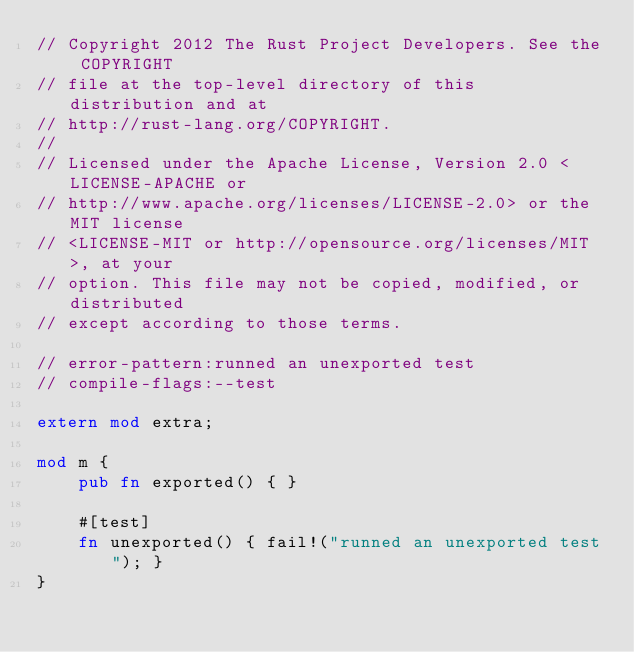Convert code to text. <code><loc_0><loc_0><loc_500><loc_500><_Rust_>// Copyright 2012 The Rust Project Developers. See the COPYRIGHT
// file at the top-level directory of this distribution and at
// http://rust-lang.org/COPYRIGHT.
//
// Licensed under the Apache License, Version 2.0 <LICENSE-APACHE or
// http://www.apache.org/licenses/LICENSE-2.0> or the MIT license
// <LICENSE-MIT or http://opensource.org/licenses/MIT>, at your
// option. This file may not be copied, modified, or distributed
// except according to those terms.

// error-pattern:runned an unexported test
// compile-flags:--test

extern mod extra;

mod m {
    pub fn exported() { }

    #[test]
    fn unexported() { fail!("runned an unexported test"); }
}
</code> 